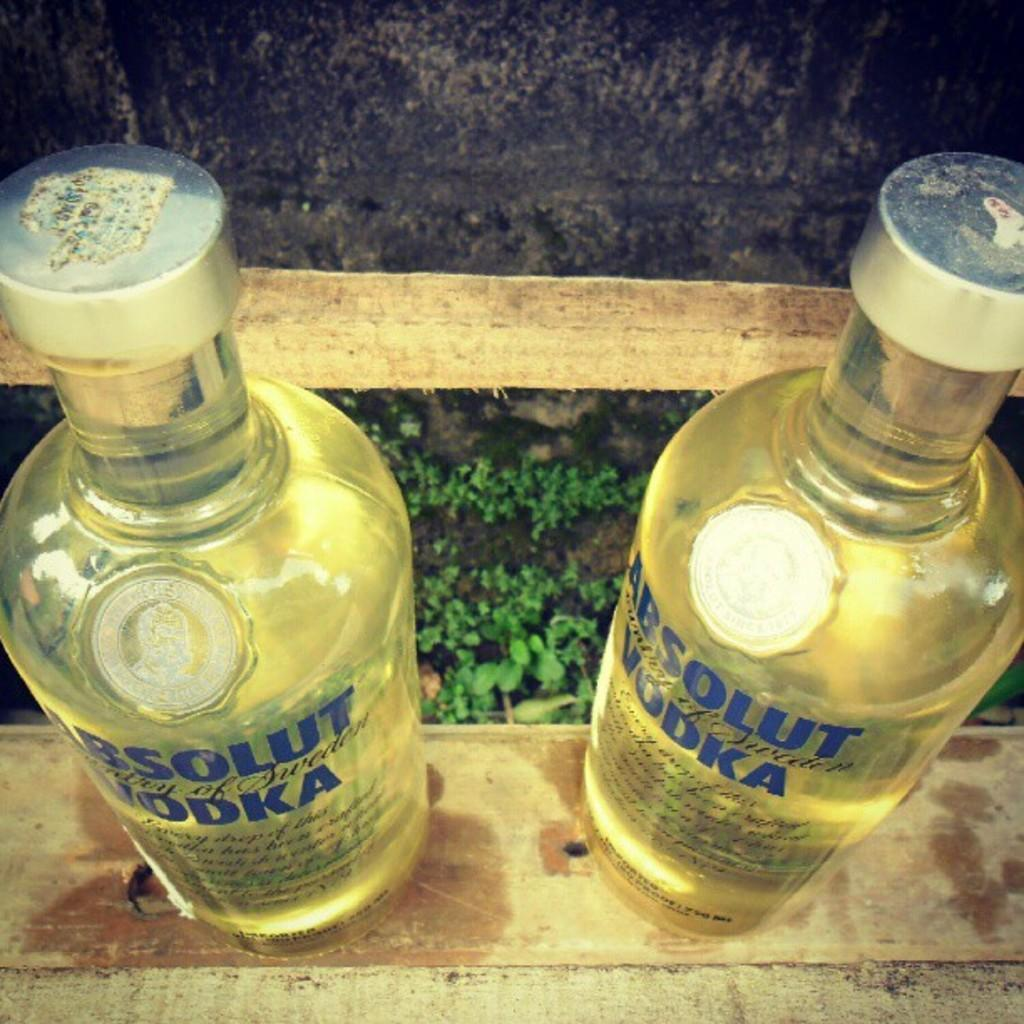Provide a one-sentence caption for the provided image. Two bottles of Absolut vodka are sitting on a wooden railing. 